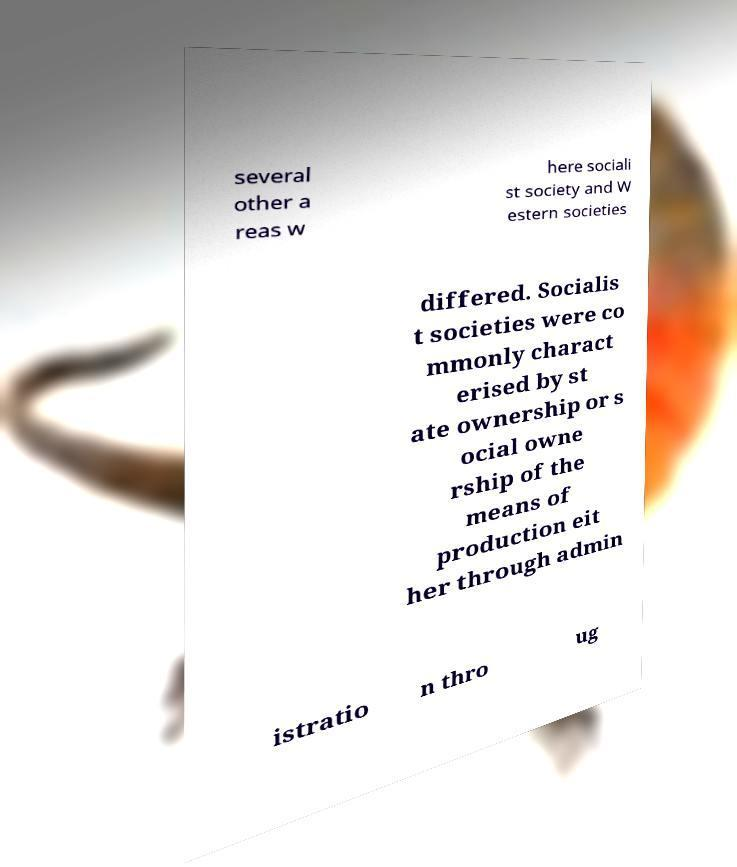Could you assist in decoding the text presented in this image and type it out clearly? several other a reas w here sociali st society and W estern societies differed. Socialis t societies were co mmonly charact erised by st ate ownership or s ocial owne rship of the means of production eit her through admin istratio n thro ug 